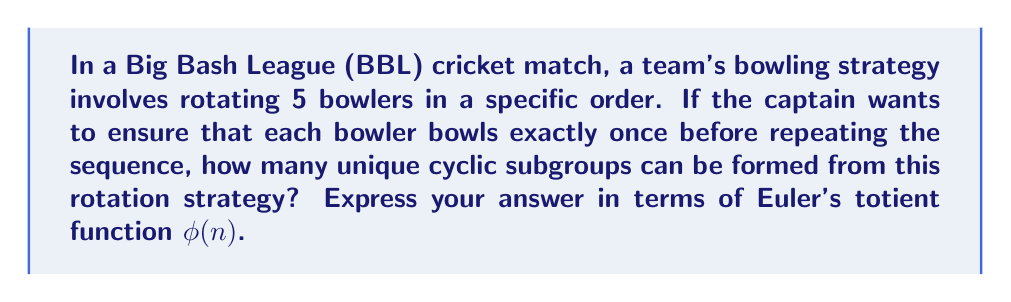Solve this math problem. To solve this problem, we need to consider the properties of cyclic groups and Euler's totient function:

1) The rotation strategy forms a cyclic group of order 5, as there are 5 bowlers in the sequence.

2) The number of unique cyclic subgroups in a cyclic group of order n is equal to the number of divisors of n.

3) For a prime number p, the divisors are always 1 and p itself.

4) 5 is a prime number.

5) Euler's totient function φ(n) for a prime number p is given by:
   $$φ(p) = p - 1$$

6) The number of unique cyclic subgroups of a cyclic group of prime order p is always 2: 
   - The trivial subgroup {e} (identity element)
   - The entire group itself

Therefore, the number of unique cyclic subgroups in this rotation strategy is 2.

To express this in terms of Euler's totient function:
$$2 = φ(5) + 1$$

This formula holds true for any prime number p:
The number of unique cyclic subgroups = φ(p) + 1
Answer: $φ(5) + 1$ or $2$ 